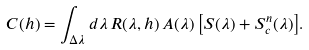<formula> <loc_0><loc_0><loc_500><loc_500>C ( h ) = \int _ { \Delta \lambda } { d \lambda \, R ( \lambda , h ) \, A ( \lambda ) \left [ S ( \lambda ) + S _ { c } ^ { n } ( \lambda ) \right ] } .</formula> 